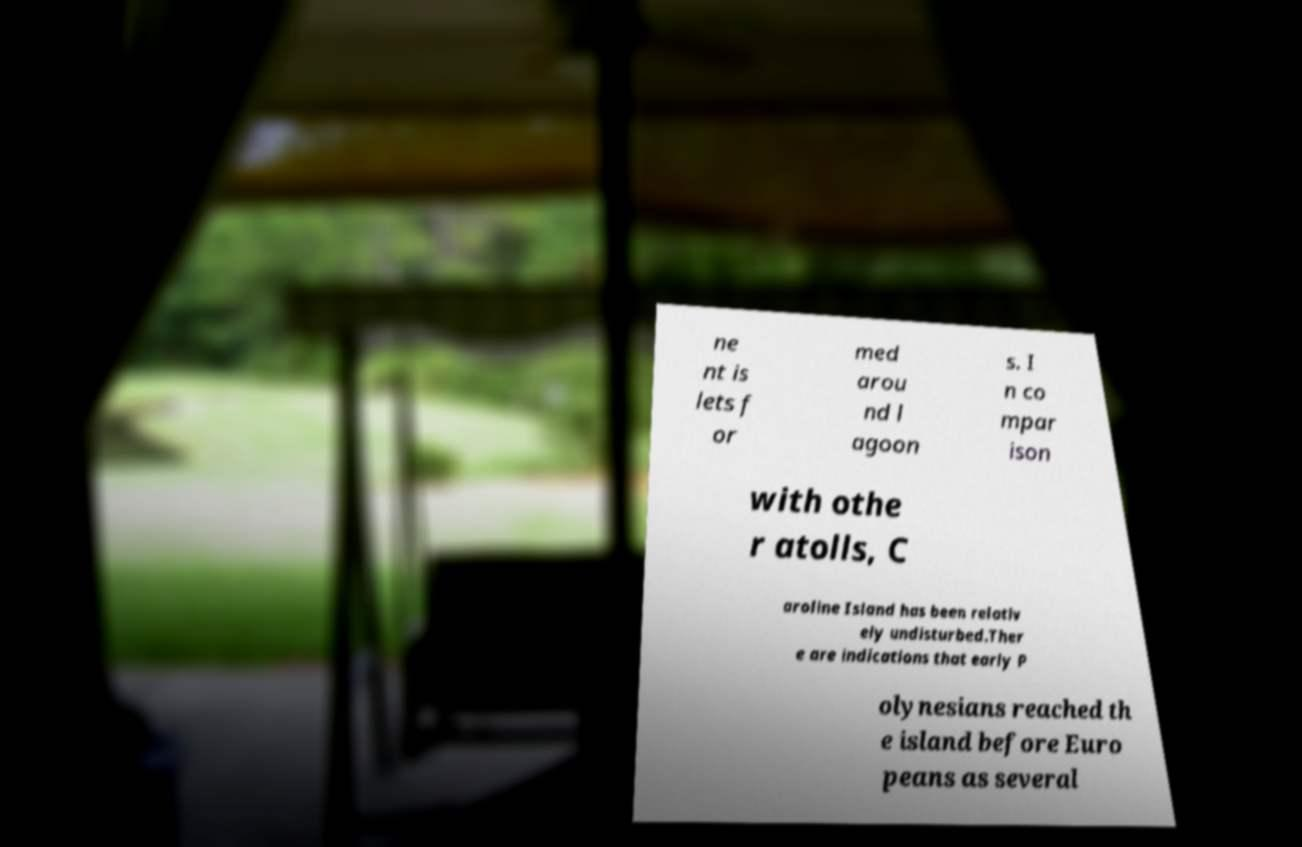Please identify and transcribe the text found in this image. ne nt is lets f or med arou nd l agoon s. I n co mpar ison with othe r atolls, C aroline Island has been relativ ely undisturbed.Ther e are indications that early P olynesians reached th e island before Euro peans as several 